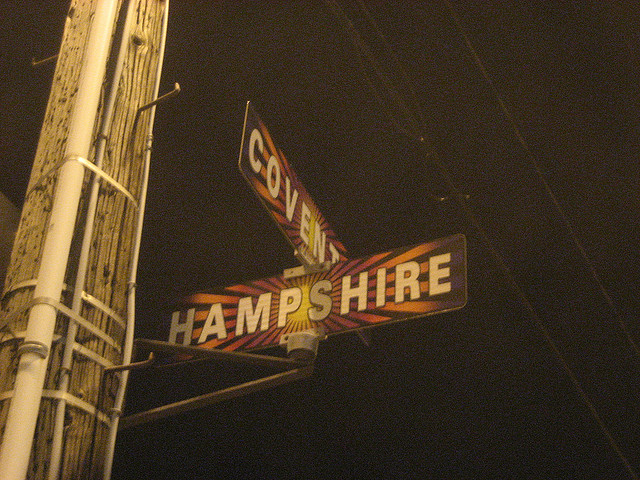Read all the text in this image. COVEN HAMPS HIRE 